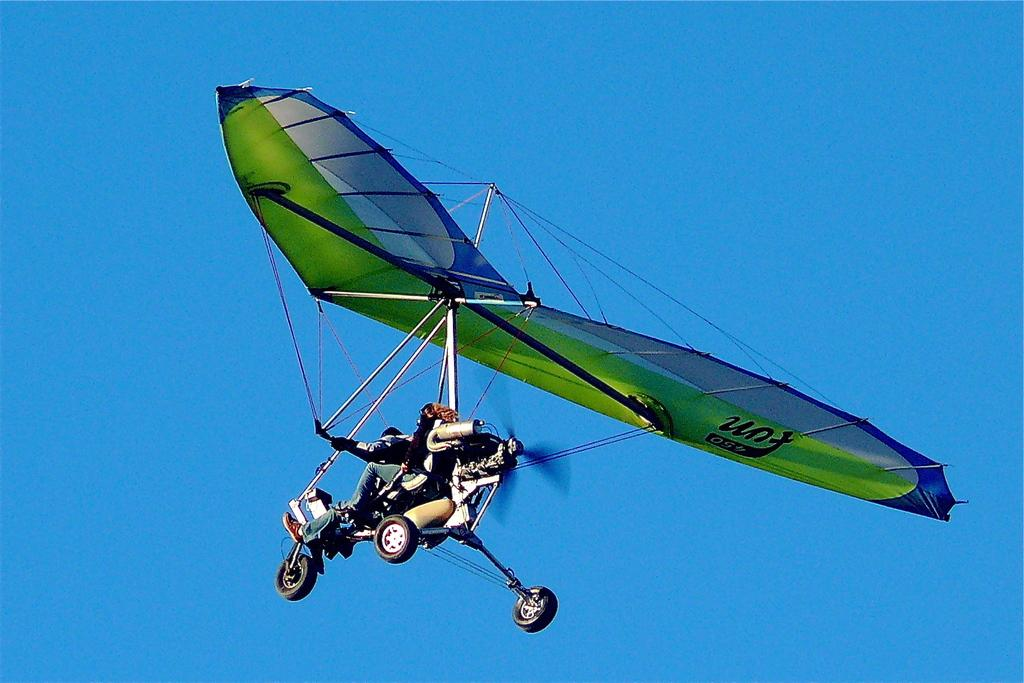What type of vehicle is in the picture? There is an ultralight aviation in the picture. What color is the ultralight aviation? The ultralight aviation is green in color. What is the ultralight aviation doing in the picture? The ultralight aviation is flying in the sky. What type of lipstick is being applied to the ultralight aviation in the image? There is no lipstick or any application of it in the image; it features an ultralight aviation flying in the sky. 